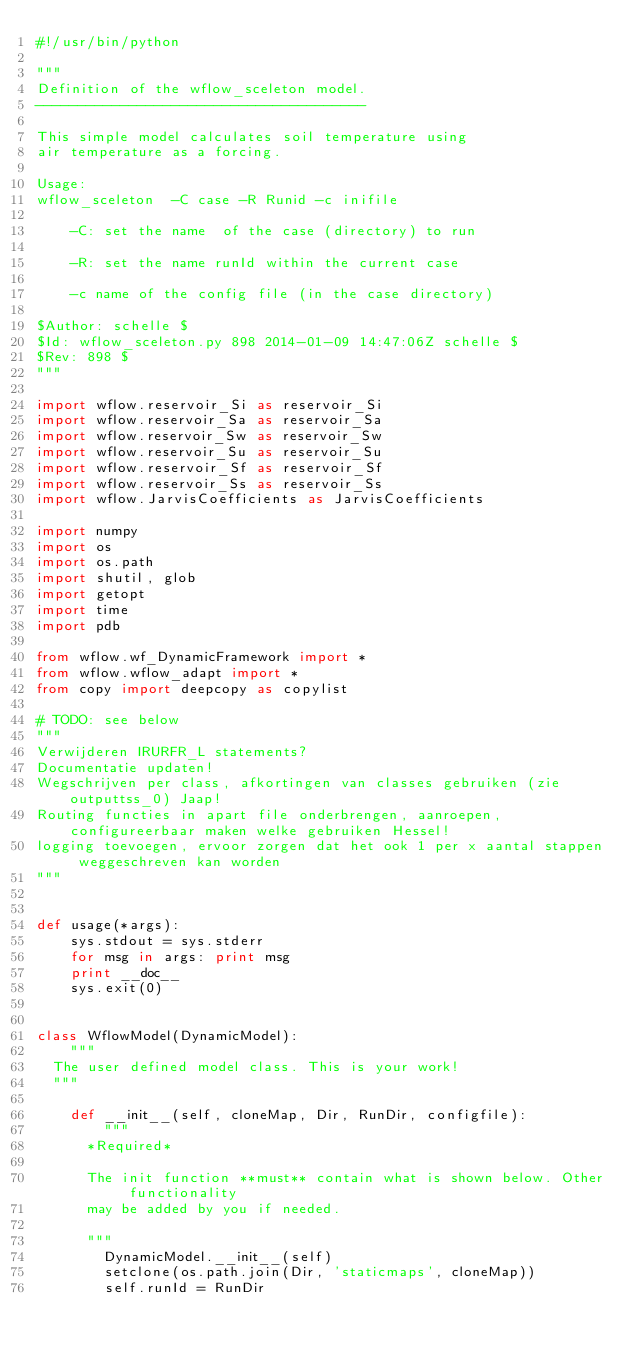<code> <loc_0><loc_0><loc_500><loc_500><_Python_>#!/usr/bin/python

"""
Definition of the wflow_sceleton model.
---------------------------------------

This simple model calculates soil temperature using
air temperature as a forcing.

Usage:
wflow_sceleton  -C case -R Runid -c inifile

    -C: set the name  of the case (directory) to run
    
    -R: set the name runId within the current case
    
    -c name of the config file (in the case directory)
    
$Author: schelle $
$Id: wflow_sceleton.py 898 2014-01-09 14:47:06Z schelle $
$Rev: 898 $
"""

import wflow.reservoir_Si as reservoir_Si
import wflow.reservoir_Sa as reservoir_Sa
import wflow.reservoir_Sw as reservoir_Sw
import wflow.reservoir_Su as reservoir_Su
import wflow.reservoir_Sf as reservoir_Sf
import wflow.reservoir_Ss as reservoir_Ss
import wflow.JarvisCoefficients as JarvisCoefficients

import numpy
import os
import os.path
import shutil, glob
import getopt
import time
import pdb

from wflow.wf_DynamicFramework import *
from wflow.wflow_adapt import *
from copy import deepcopy as copylist

# TODO: see below
"""
Verwijderen IRURFR_L statements?
Documentatie updaten!
Wegschrijven per class, afkortingen van classes gebruiken (zie outputtss_0) Jaap!
Routing functies in apart file onderbrengen, aanroepen, configureerbaar maken welke gebruiken Hessel!
logging toevoegen, ervoor zorgen dat het ook 1 per x aantal stappen weggeschreven kan worden
"""


def usage(*args):
    sys.stdout = sys.stderr
    for msg in args: print msg
    print __doc__
    sys.exit(0)


class WflowModel(DynamicModel):
    """
  The user defined model class. This is your work!
  """

    def __init__(self, cloneMap, Dir, RunDir, configfile):
        """
      *Required*
      
      The init function **must** contain what is shown below. Other functionality
      may be added by you if needed.
      
      """
        DynamicModel.__init__(self)
        setclone(os.path.join(Dir, 'staticmaps', cloneMap))
        self.runId = RunDir</code> 